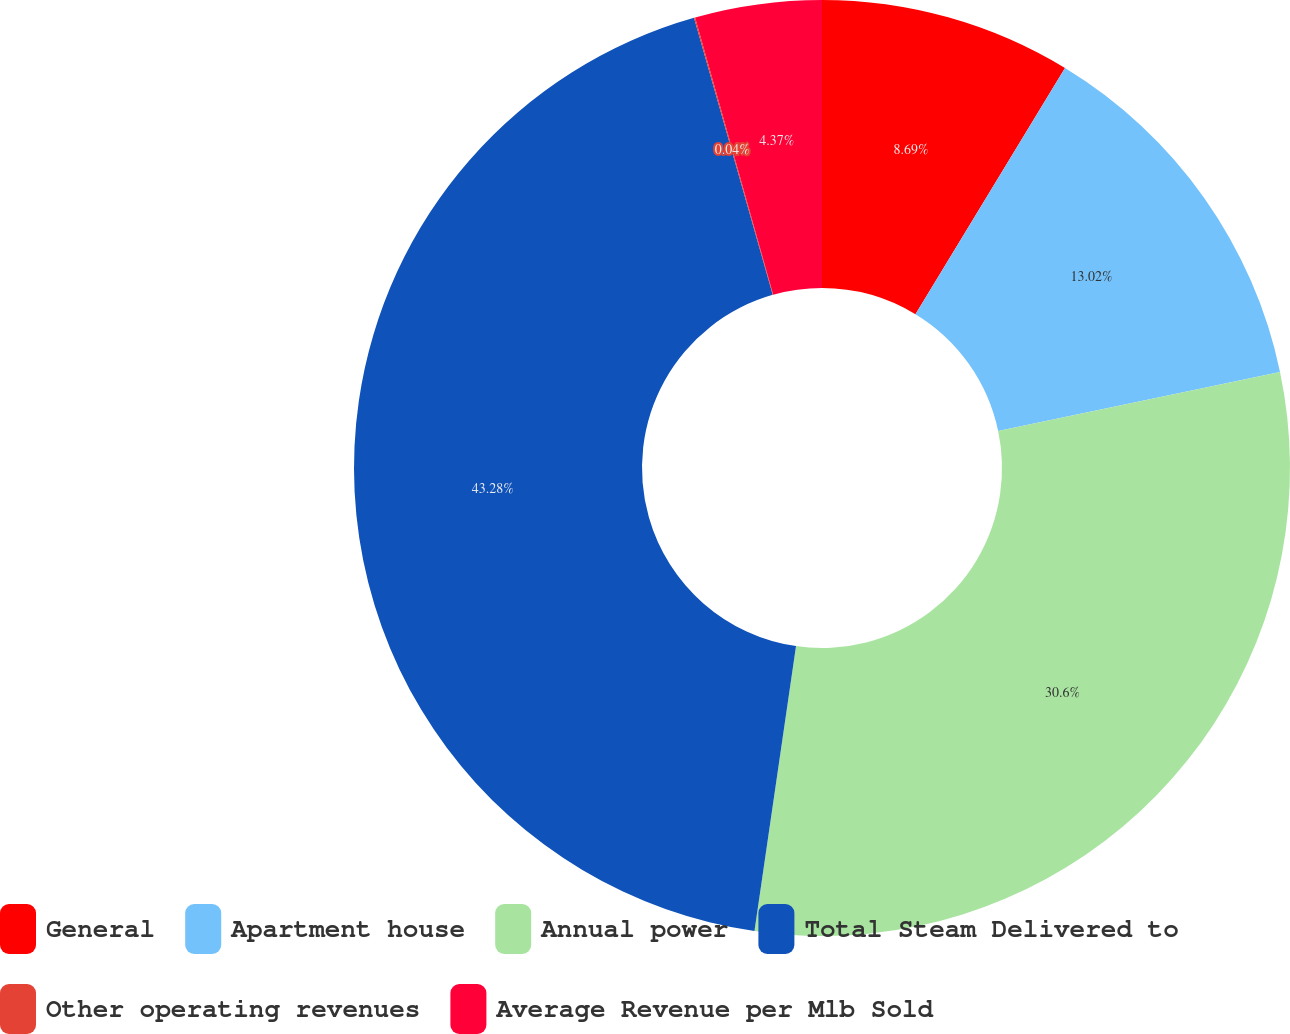Convert chart to OTSL. <chart><loc_0><loc_0><loc_500><loc_500><pie_chart><fcel>General<fcel>Apartment house<fcel>Annual power<fcel>Total Steam Delivered to<fcel>Other operating revenues<fcel>Average Revenue per Mlb Sold<nl><fcel>8.69%<fcel>13.02%<fcel>30.6%<fcel>43.29%<fcel>0.04%<fcel>4.37%<nl></chart> 